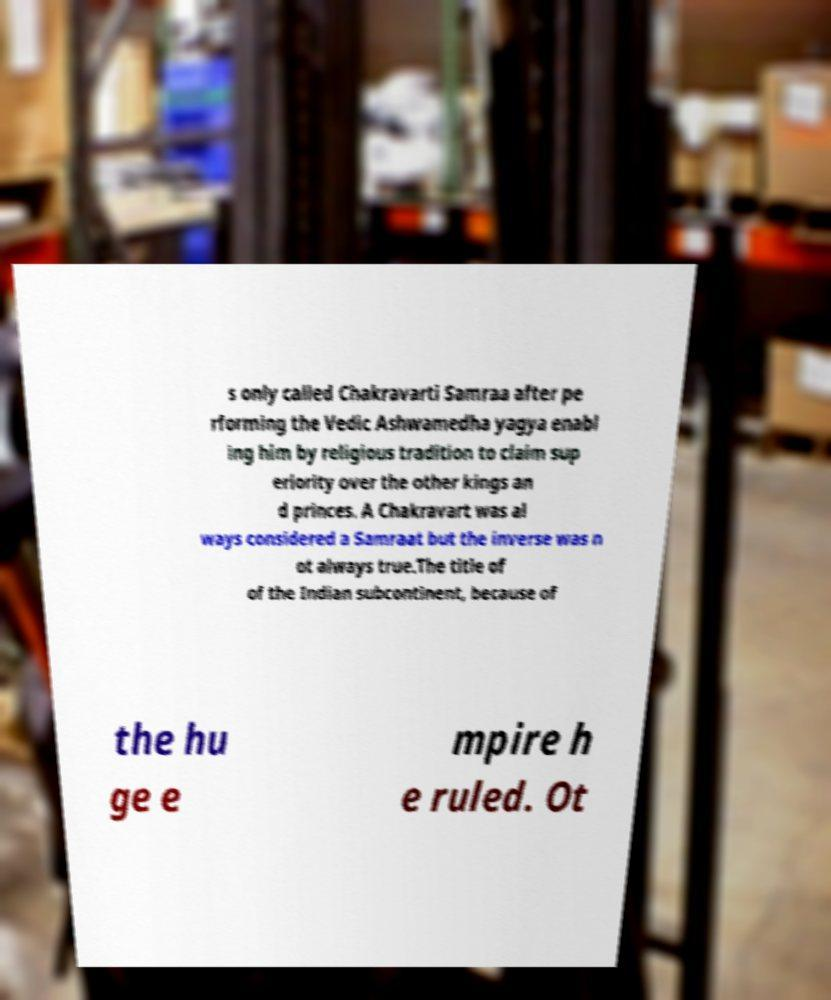There's text embedded in this image that I need extracted. Can you transcribe it verbatim? s only called Chakravarti Samraa after pe rforming the Vedic Ashwamedha yagya enabl ing him by religious tradition to claim sup eriority over the other kings an d princes. A Chakravart was al ways considered a Samraat but the inverse was n ot always true.The title of of the Indian subcontinent, because of the hu ge e mpire h e ruled. Ot 